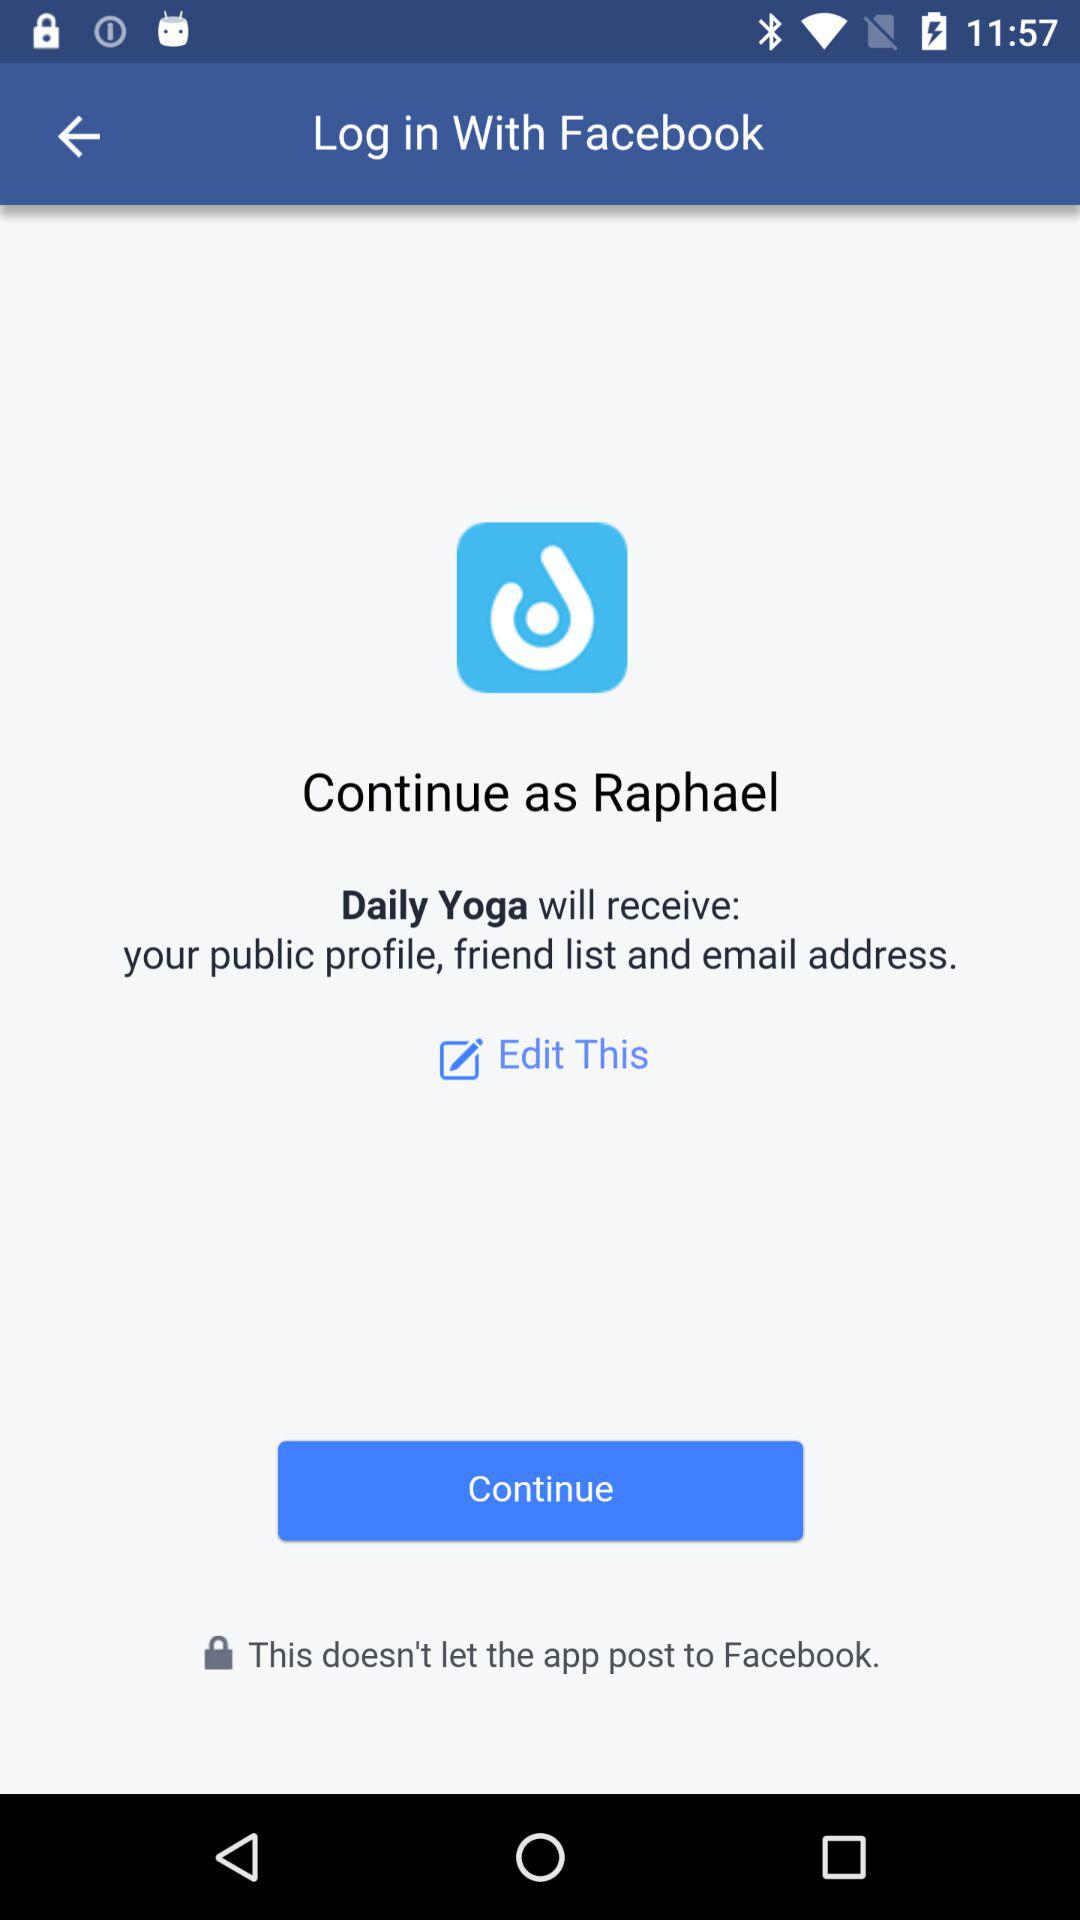What is the name of the user? The name of the user is Raphael. 